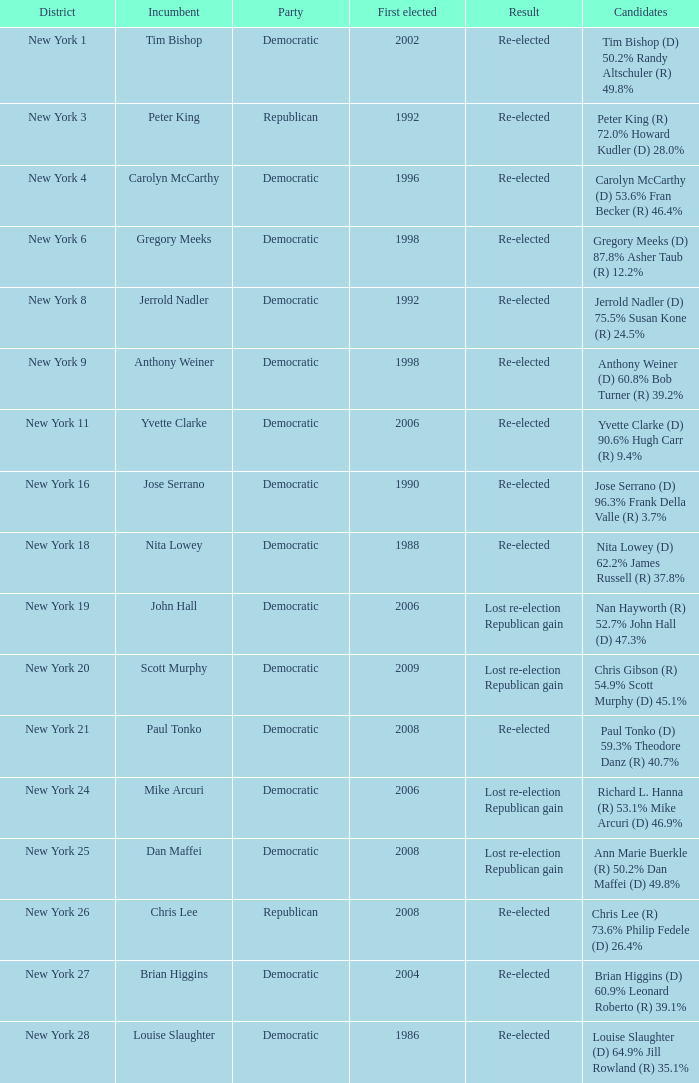Determine the effect for new york Re-elected. 